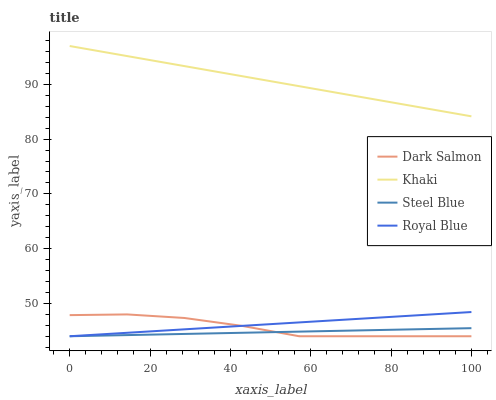Does Steel Blue have the minimum area under the curve?
Answer yes or no. Yes. Does Khaki have the maximum area under the curve?
Answer yes or no. Yes. Does Dark Salmon have the minimum area under the curve?
Answer yes or no. No. Does Dark Salmon have the maximum area under the curve?
Answer yes or no. No. Is Royal Blue the smoothest?
Answer yes or no. Yes. Is Dark Salmon the roughest?
Answer yes or no. Yes. Is Khaki the smoothest?
Answer yes or no. No. Is Khaki the roughest?
Answer yes or no. No. Does Khaki have the lowest value?
Answer yes or no. No. Does Khaki have the highest value?
Answer yes or no. Yes. Does Dark Salmon have the highest value?
Answer yes or no. No. Is Steel Blue less than Khaki?
Answer yes or no. Yes. Is Khaki greater than Royal Blue?
Answer yes or no. Yes. Does Royal Blue intersect Steel Blue?
Answer yes or no. Yes. Is Royal Blue less than Steel Blue?
Answer yes or no. No. Is Royal Blue greater than Steel Blue?
Answer yes or no. No. Does Steel Blue intersect Khaki?
Answer yes or no. No. 